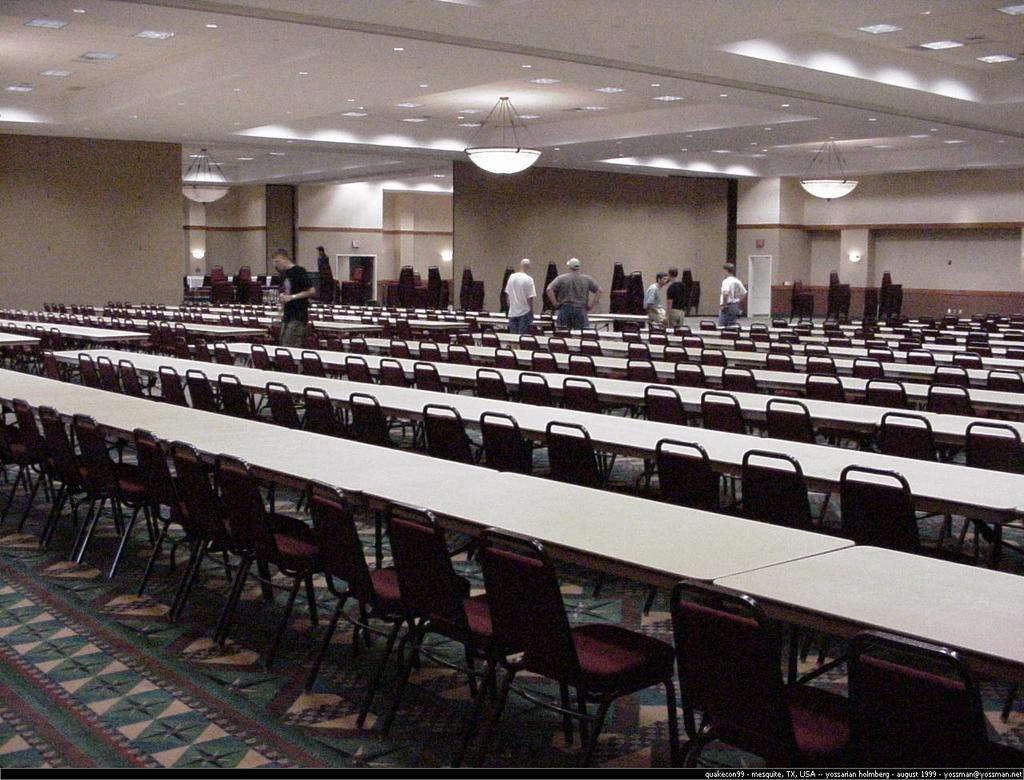What type of furniture is present in the image? There are chairs and tables in the image. What are the people in the image doing? The people standing in the image are not performing any specific action that can be determined from the facts. What architectural element is visible in the image? There is a wall visible in the image. What part of the room is visible in the image? The ceiling is present in the image. What is used for illumination in the image? There are lights in the image. What type of cloth is draped over the scarecrow in the image? There is no scarecrow present in the image. 